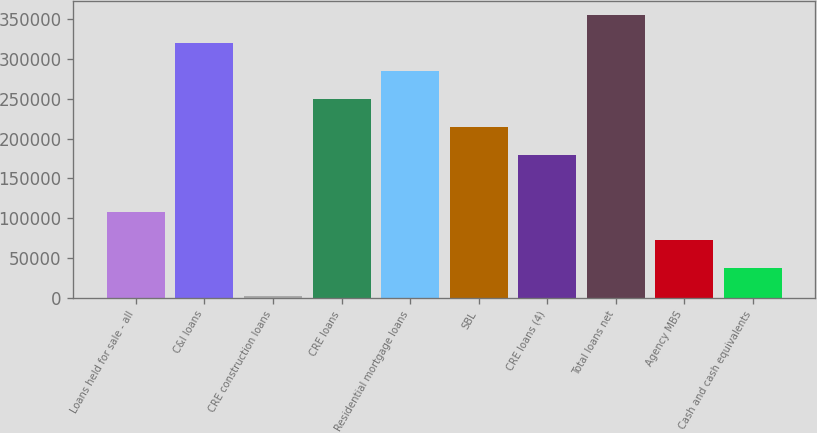Convert chart to OTSL. <chart><loc_0><loc_0><loc_500><loc_500><bar_chart><fcel>Loans held for sale - all<fcel>C&I loans<fcel>CRE construction loans<fcel>CRE loans<fcel>Residential mortgage loans<fcel>SBL<fcel>CRE loans (4)<fcel>Total loans net<fcel>Agency MBS<fcel>Cash and cash equivalents<nl><fcel>108233<fcel>320008<fcel>2346<fcel>249417<fcel>284712<fcel>214121<fcel>178825<fcel>355304<fcel>72937.6<fcel>37641.8<nl></chart> 